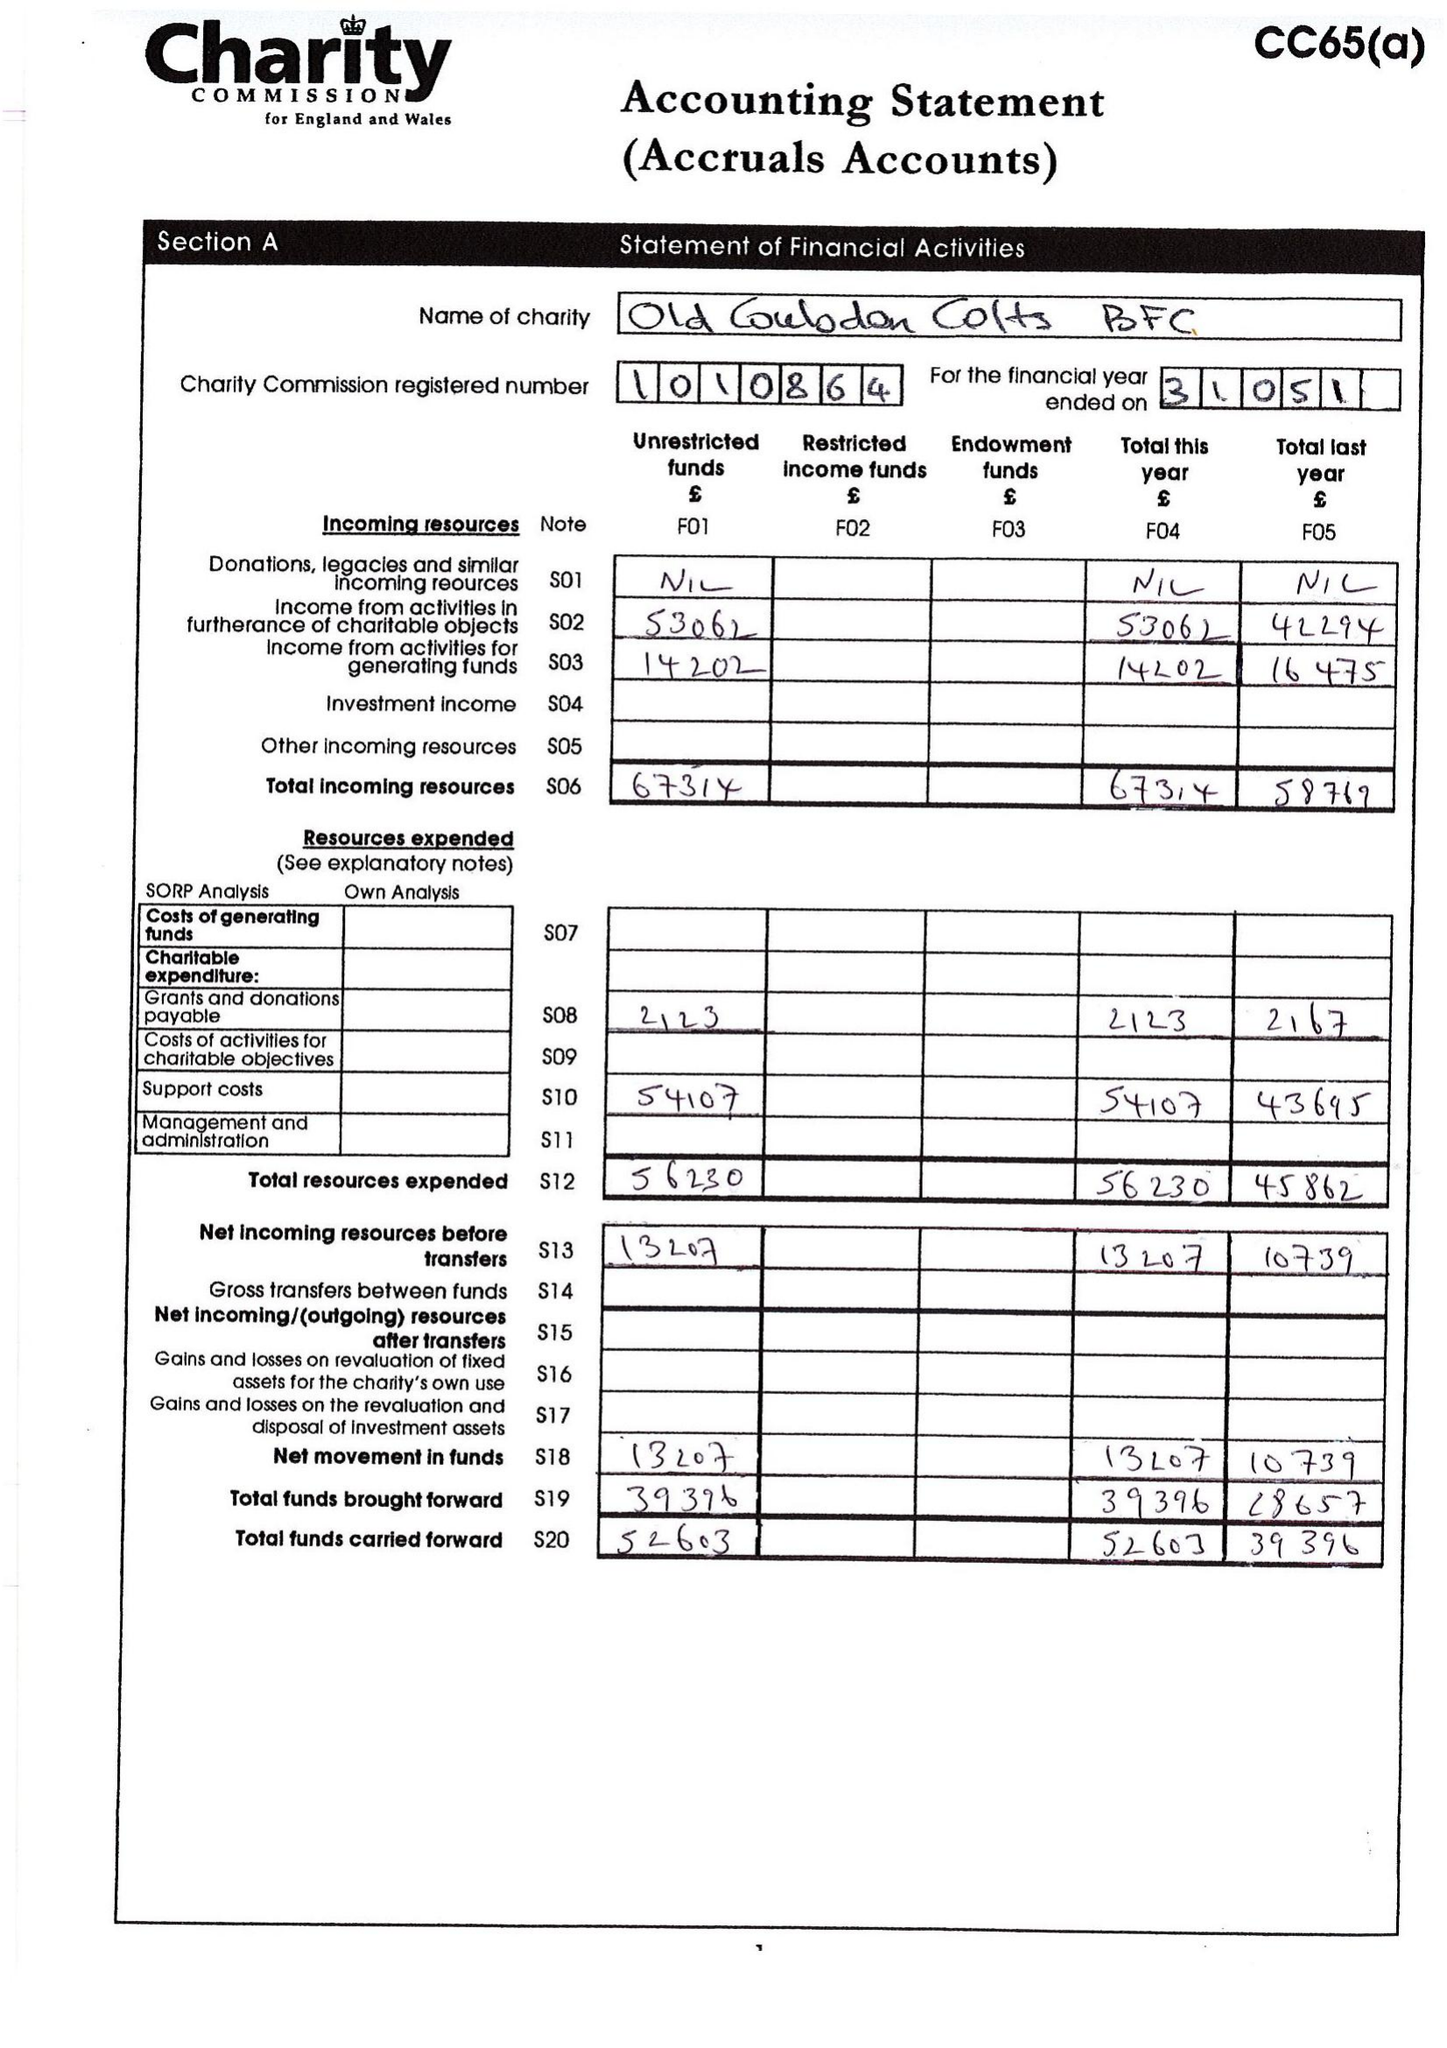What is the value for the charity_number?
Answer the question using a single word or phrase. 1010864 